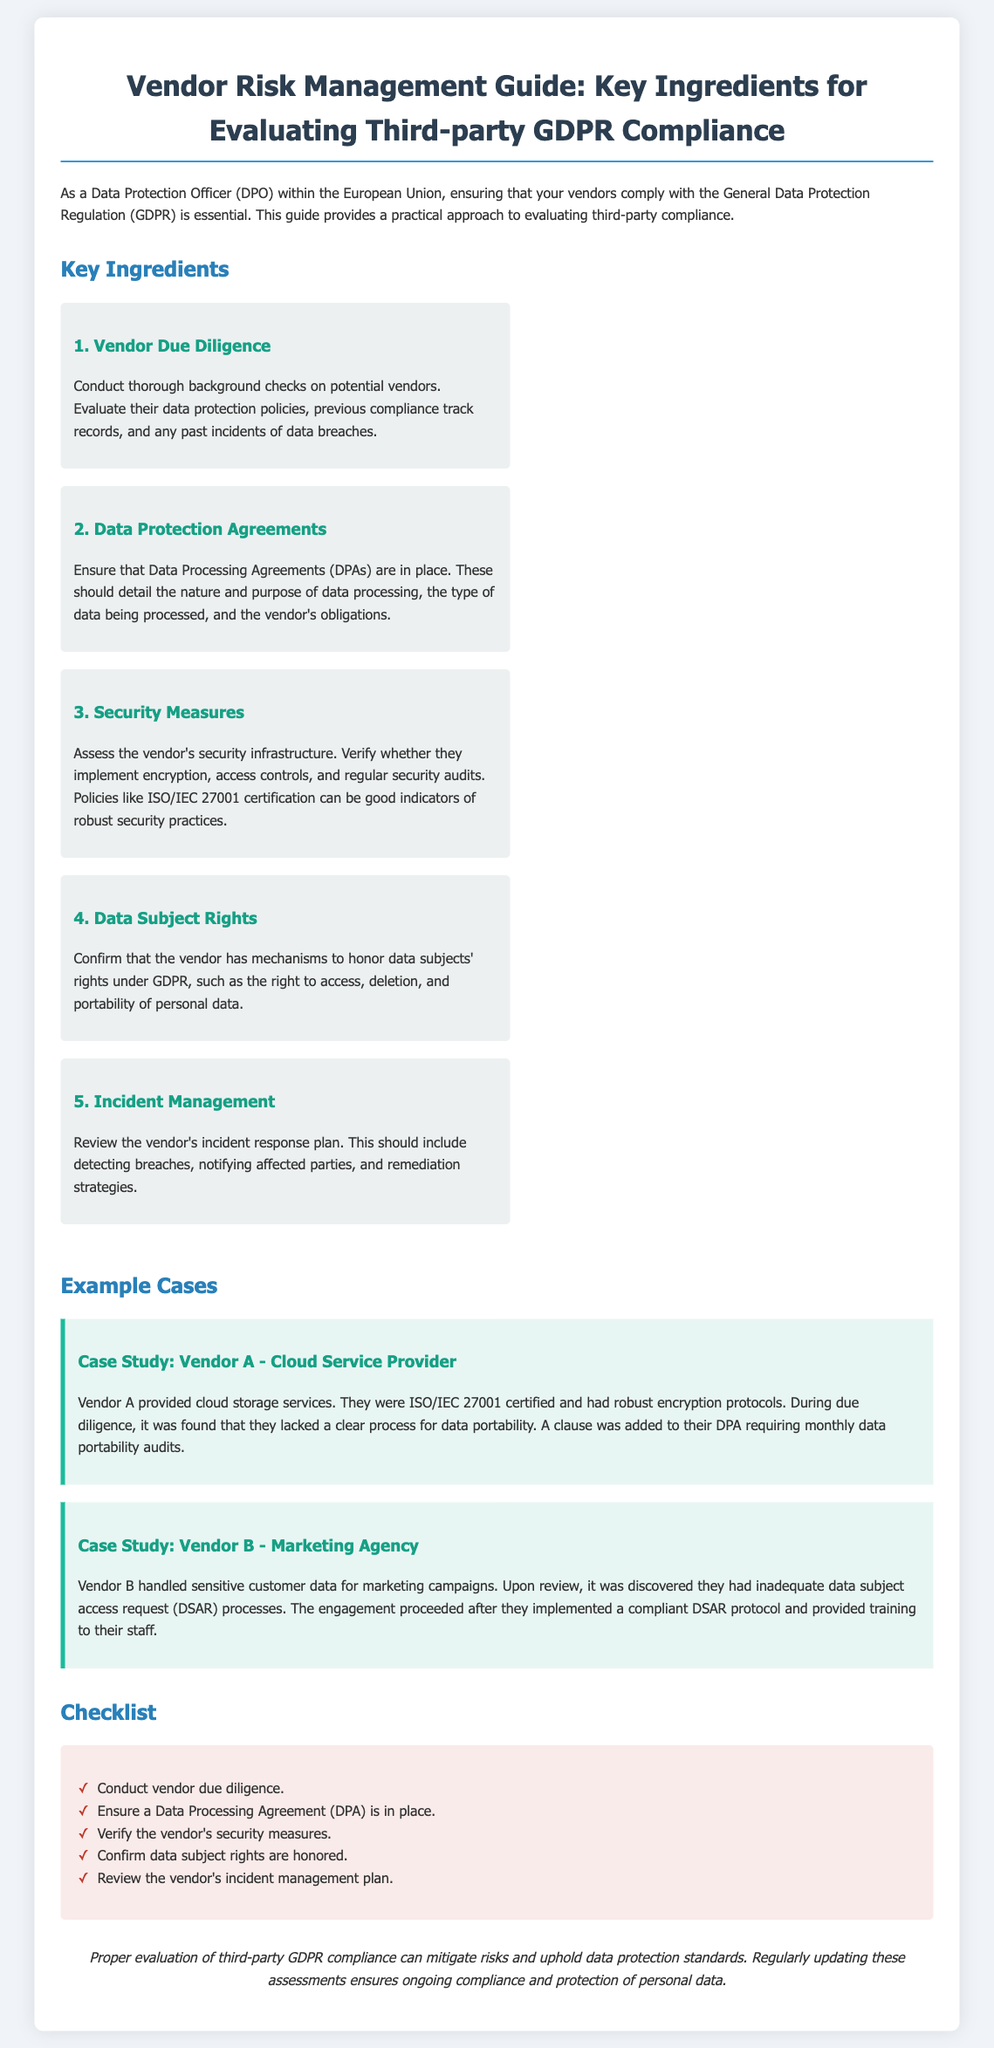What is the title of the document? The title is provided in the heading of the document.
Answer: Vendor Risk Management Guide: Key Ingredients for Evaluating Third-party GDPR Compliance How many key ingredients are listed in the document? The number of key ingredients is stated in the section about them.
Answer: 5 What does Vendor Due Diligence involve? The document specifies a process regarding background checks on potential vendors.
Answer: Conduct thorough background checks Which certification indicates robust security practices? The document mentions a specific certification within the security measures ingredient.
Answer: ISO/IEC 27001 What important right must vendors honor under GDPR? The document discusses specific rights related to data subjects.
Answer: Right to access What did Vendor A lack according to the case study? The case study discusses a specific deficiency in Vendor A's processes.
Answer: A clear process for data portability What is one action recommended in the checklist? The checklist offers a condensed list of actions regarding vendor compliance.
Answer: Conduct vendor due diligence What should the vendor's incident response plan include? The document defines elements that the incident management plan must cover.
Answer: Detecting breaches 